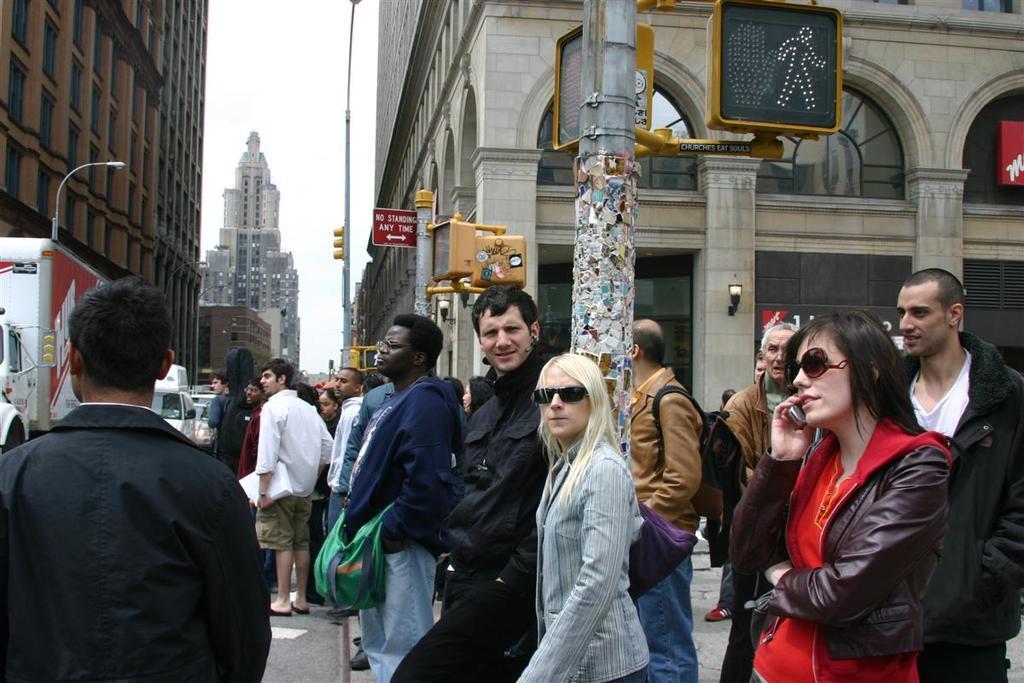How would you summarize this image in a sentence or two? In this image there is the sky towards the top of the image, there are buildings towards the left of the image, there are buildings towards the right of the image, there are poles towards the top of the image, there are street lights, there are boards, there is text on the boards, there is road towards the bottom of the image, there are vehicles on the road, there are a group of persons standing on the road, they are holding an object, they are wearing bags. 